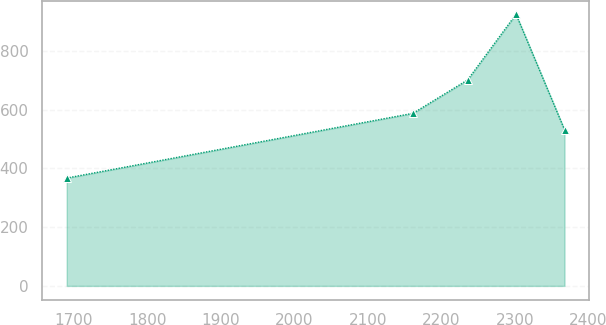<chart> <loc_0><loc_0><loc_500><loc_500><line_chart><ecel><fcel>Unnamed: 1<nl><fcel>1690.29<fcel>367<nl><fcel>2161.51<fcel>587.32<nl><fcel>2235.82<fcel>700.73<nl><fcel>2301.79<fcel>924.41<nl><fcel>2367.76<fcel>531.58<nl></chart> 